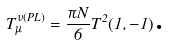Convert formula to latex. <formula><loc_0><loc_0><loc_500><loc_500>T _ { \mu } ^ { \nu ( P L ) } = \frac { \pi N } { 6 } T ^ { 2 } ( 1 , - 1 ) \text {.}</formula> 